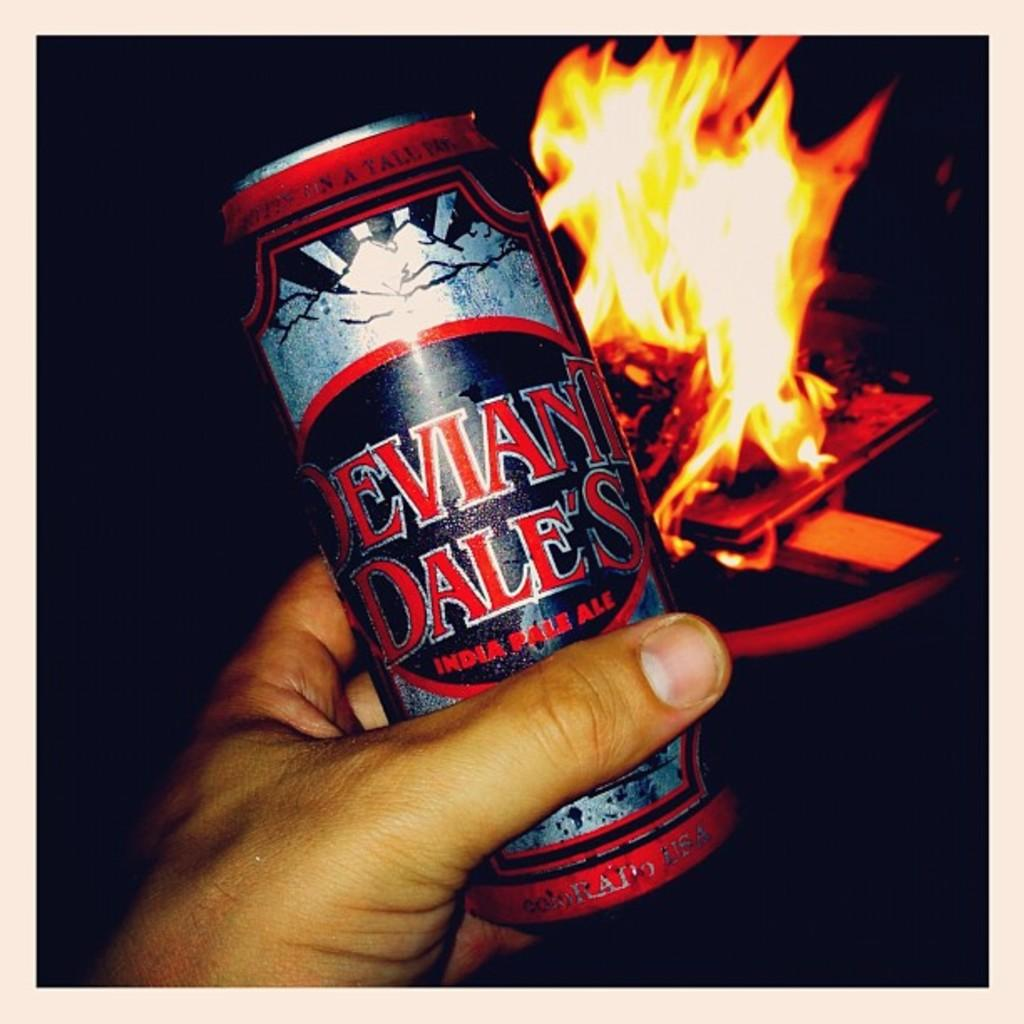Provide a one-sentence caption for the provided image. A hand is holding a can of India pale ale in front of a fire. 